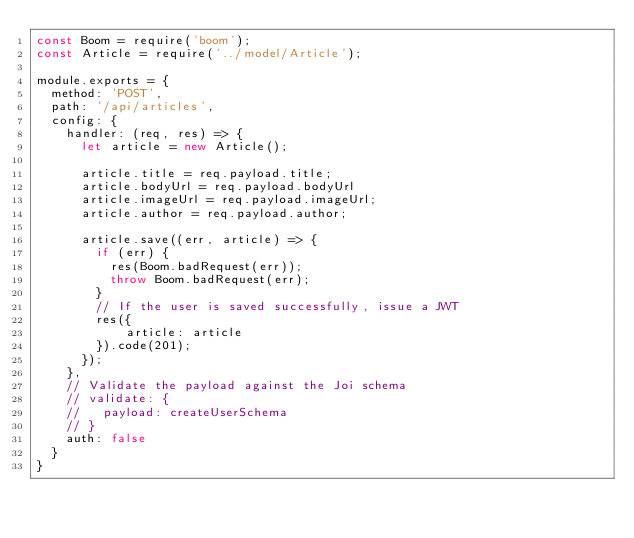<code> <loc_0><loc_0><loc_500><loc_500><_JavaScript_>const Boom = require('boom');
const Article = require('../model/Article');

module.exports = {
  method: 'POST',
  path: '/api/articles',
  config: {
    handler: (req, res) => {
      let article = new Article();

      article.title = req.payload.title;
      article.bodyUrl = req.payload.bodyUrl
      article.imageUrl = req.payload.imageUrl;
      article.author = req.payload.author;
  
      article.save((err, article) => {
        if (err) {
          res(Boom.badRequest(err));
          throw Boom.badRequest(err);
        }
        // If the user is saved successfully, issue a JWT
        res({
            article: article
        }).code(201);
      });  
    },
    // Validate the payload against the Joi schema
    // validate: {
    //   payload: createUserSchema
    // } 
    auth: false
  }
}</code> 